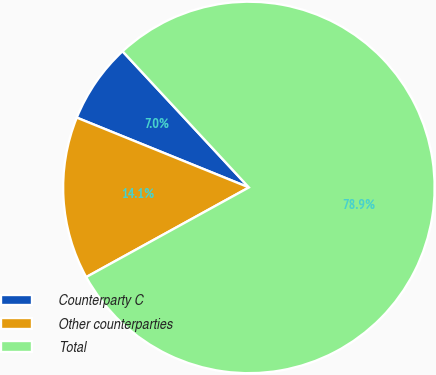Convert chart to OTSL. <chart><loc_0><loc_0><loc_500><loc_500><pie_chart><fcel>Counterparty C<fcel>Other counterparties<fcel>Total<nl><fcel>6.96%<fcel>14.15%<fcel>78.89%<nl></chart> 